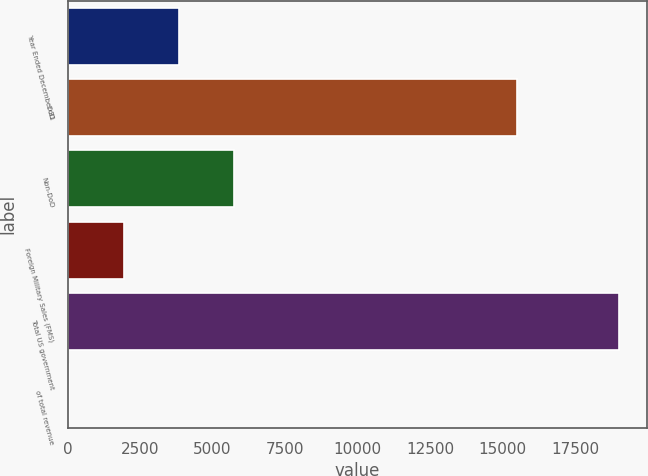Convert chart to OTSL. <chart><loc_0><loc_0><loc_500><loc_500><bar_chart><fcel>Year Ended December 31<fcel>DoD<fcel>Non-DoD<fcel>Foreign Military Sales (FMS)<fcel>Total US government<fcel>of total revenue<nl><fcel>3853<fcel>15498<fcel>5749<fcel>1957<fcel>19021<fcel>61<nl></chart> 